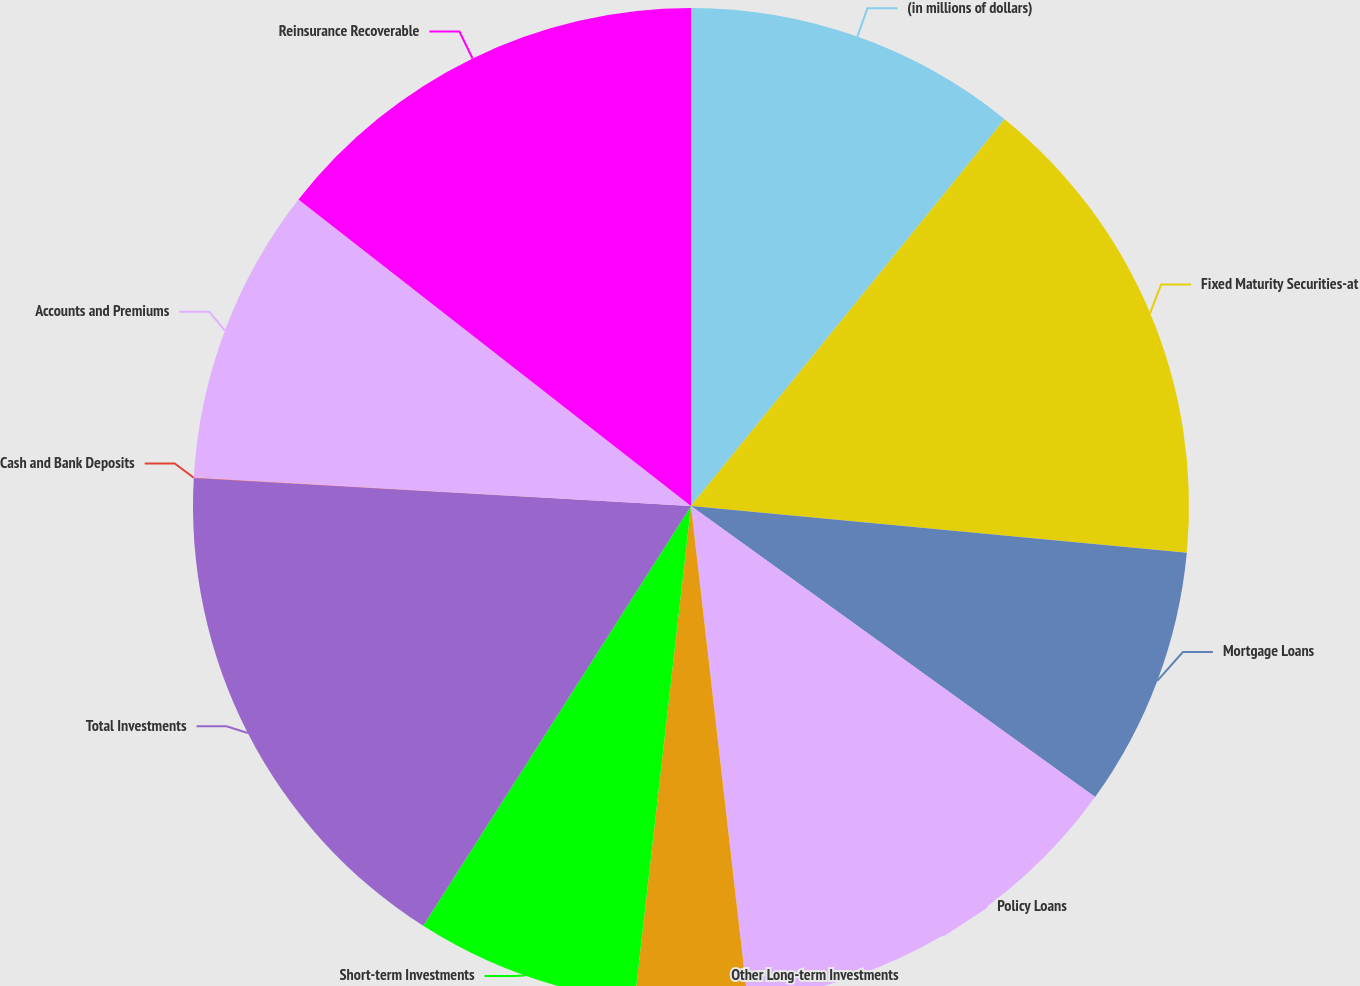Convert chart to OTSL. <chart><loc_0><loc_0><loc_500><loc_500><pie_chart><fcel>(in millions of dollars)<fcel>Fixed Maturity Securities-at<fcel>Mortgage Loans<fcel>Policy Loans<fcel>Other Long-term Investments<fcel>Short-term Investments<fcel>Total Investments<fcel>Cash and Bank Deposits<fcel>Accounts and Premiums<fcel>Reinsurance Recoverable<nl><fcel>10.84%<fcel>15.65%<fcel>8.44%<fcel>13.25%<fcel>3.62%<fcel>7.23%<fcel>16.86%<fcel>0.01%<fcel>9.64%<fcel>14.45%<nl></chart> 